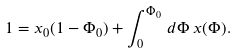Convert formula to latex. <formula><loc_0><loc_0><loc_500><loc_500>1 = x _ { 0 } ( 1 - \Phi _ { 0 } ) + \int _ { 0 } ^ { \Phi _ { 0 } } \, d \Phi \, x ( \Phi ) .</formula> 